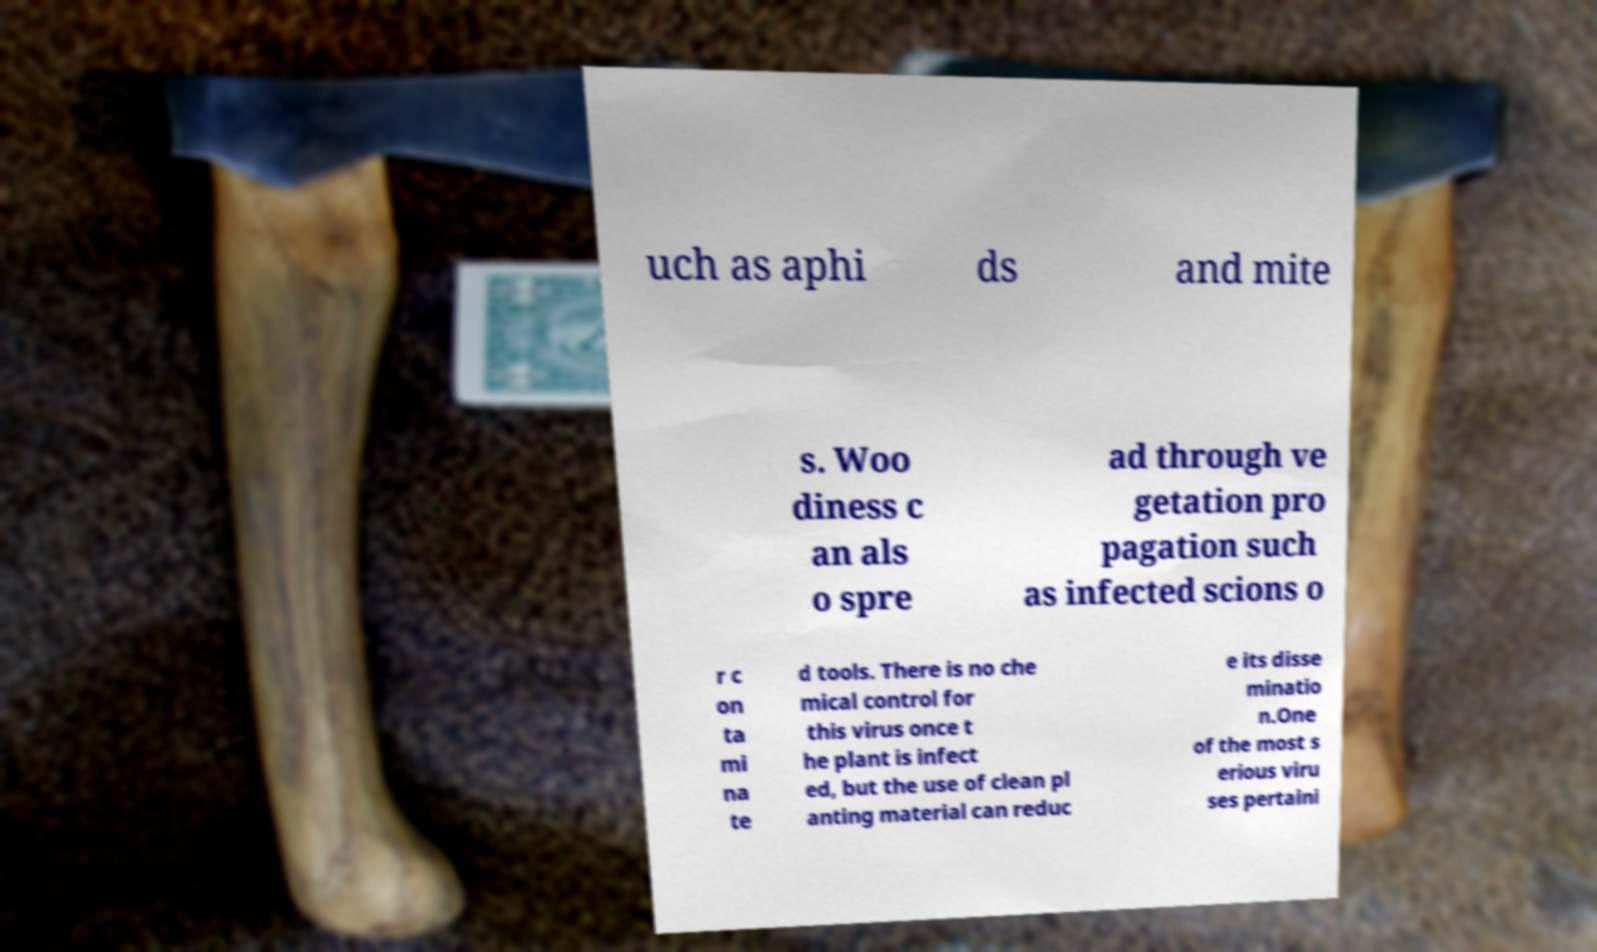I need the written content from this picture converted into text. Can you do that? uch as aphi ds and mite s. Woo diness c an als o spre ad through ve getation pro pagation such as infected scions o r c on ta mi na te d tools. There is no che mical control for this virus once t he plant is infect ed, but the use of clean pl anting material can reduc e its disse minatio n.One of the most s erious viru ses pertaini 